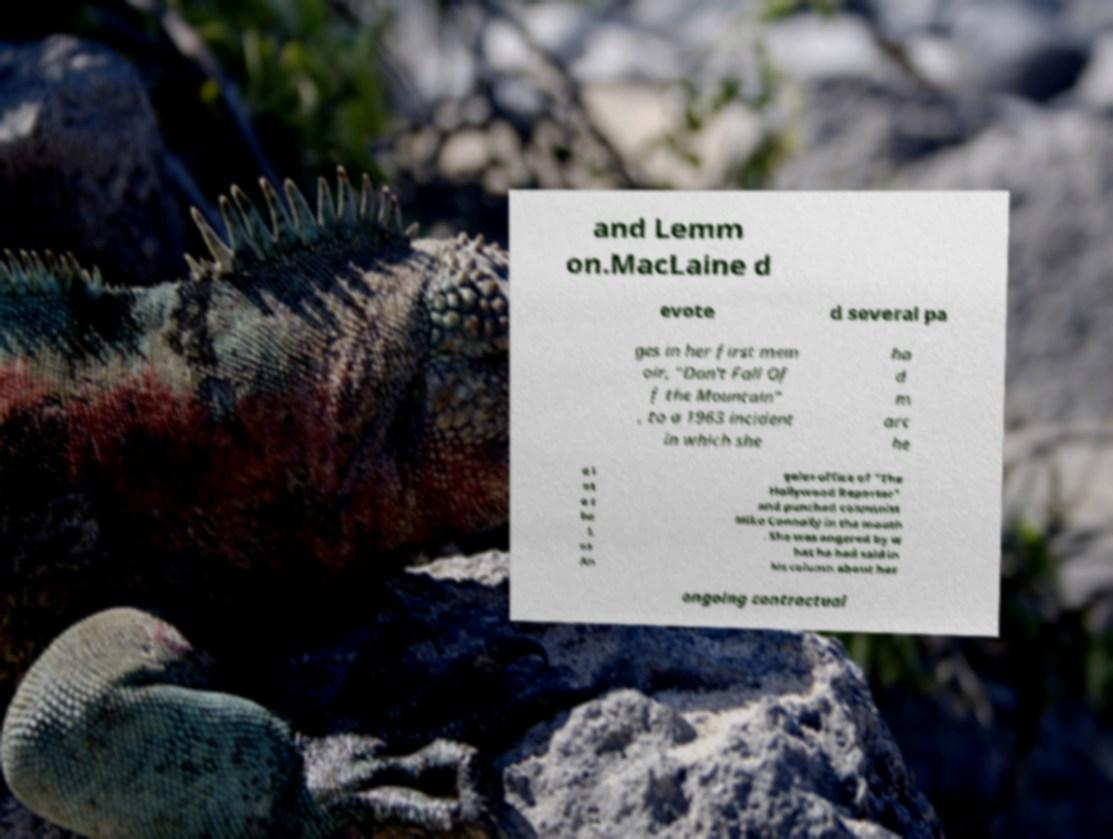I need the written content from this picture converted into text. Can you do that? and Lemm on.MacLaine d evote d several pa ges in her first mem oir, "Don't Fall Of f the Mountain" , to a 1963 incident in which she ha d m arc he d i nt o t he L os An geles office of "The Hollywood Reporter" and punched columnist Mike Connolly in the mouth . She was angered by w hat he had said in his column about her ongoing contractual 